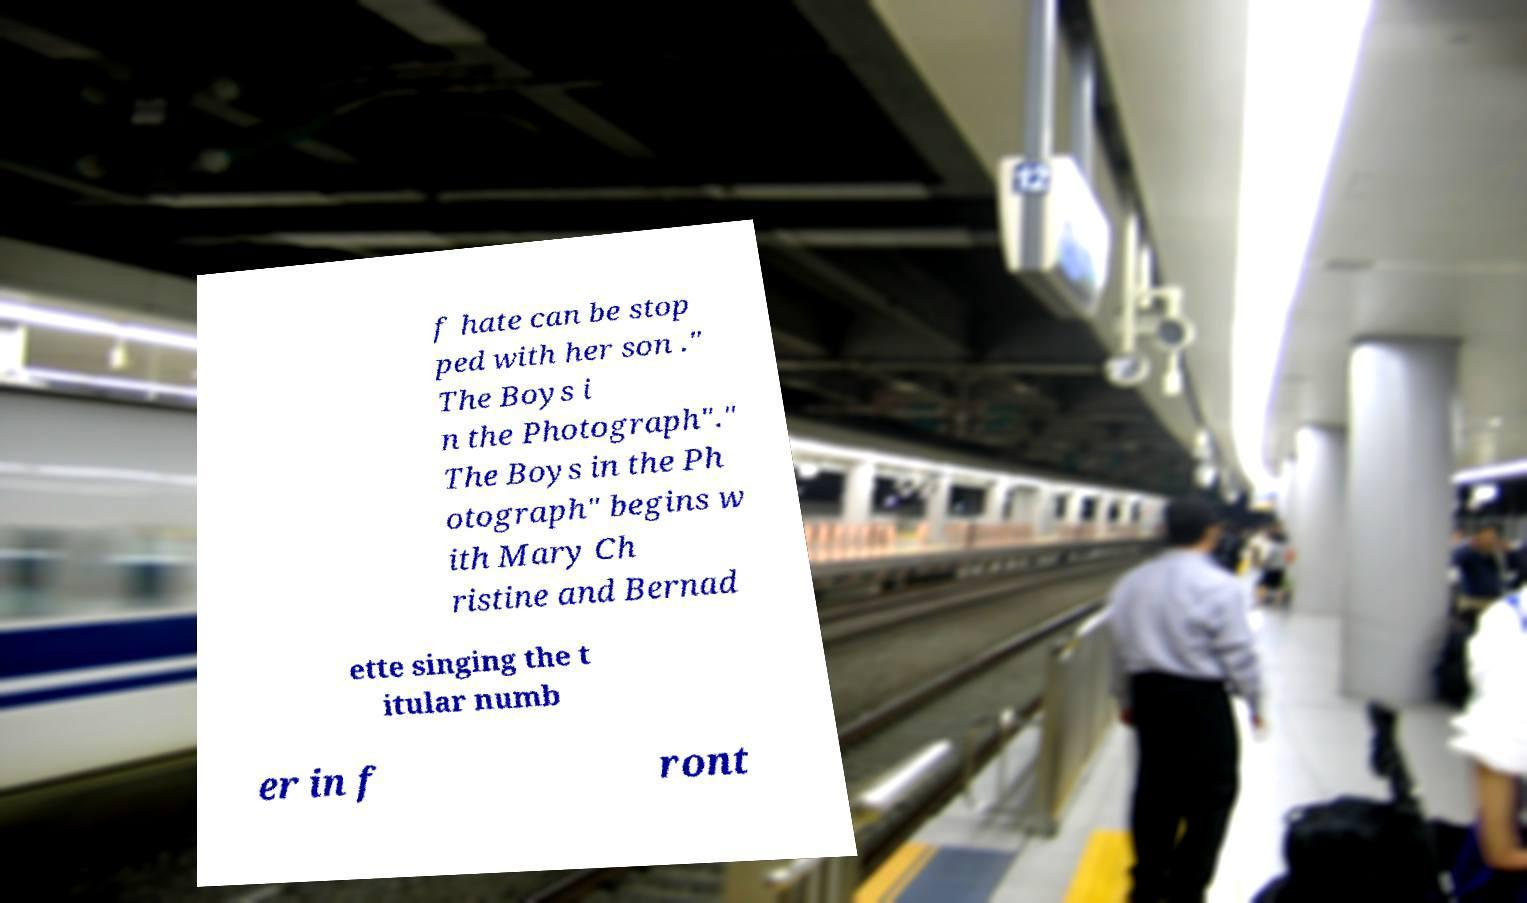For documentation purposes, I need the text within this image transcribed. Could you provide that? f hate can be stop ped with her son ." The Boys i n the Photograph"." The Boys in the Ph otograph" begins w ith Mary Ch ristine and Bernad ette singing the t itular numb er in f ront 